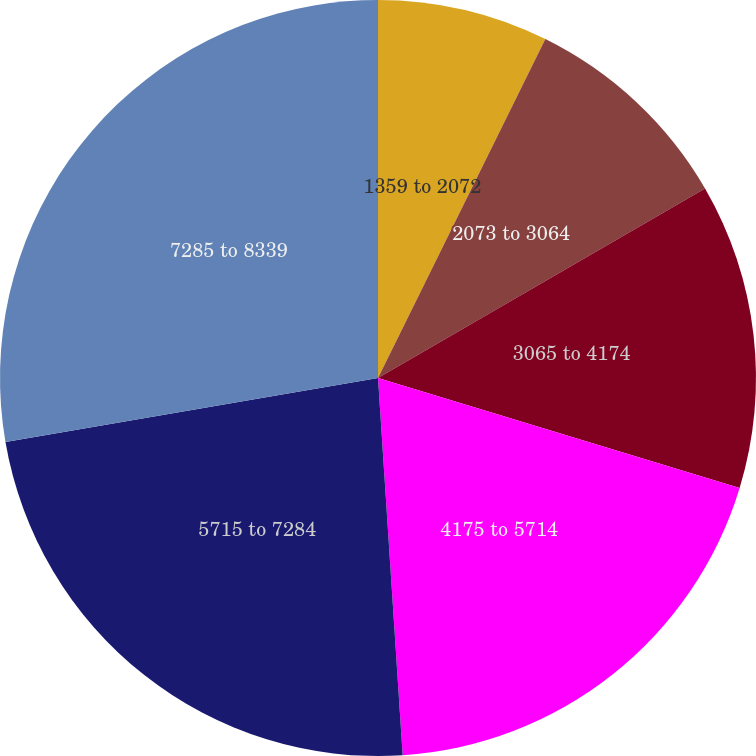Convert chart to OTSL. <chart><loc_0><loc_0><loc_500><loc_500><pie_chart><fcel>1359 to 2072<fcel>2073 to 3064<fcel>3065 to 4174<fcel>4175 to 5714<fcel>5715 to 7284<fcel>7285 to 8339<nl><fcel>7.3%<fcel>9.34%<fcel>13.06%<fcel>19.26%<fcel>23.33%<fcel>27.71%<nl></chart> 